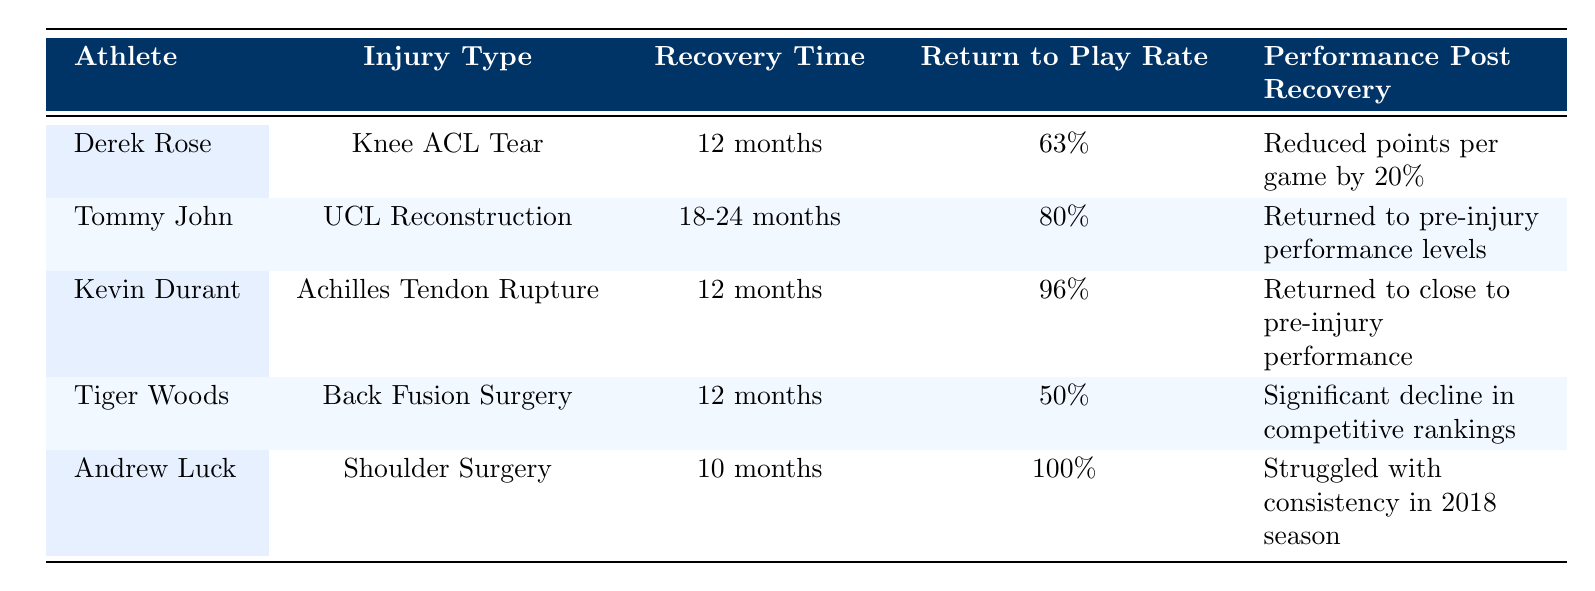What is the recovery time for Derek Rose? According to the table, the recovery time for Derek Rose who suffered from a Knee ACL Tear is noted as 12 months.
Answer: 12 months What is the return to play rate after shoulder surgery for Andrew Luck? The return to play rate for Andrew Luck after undergoing shoulder surgery is listed as 100% in the table.
Answer: 100% Which athlete experienced a significant decline in competitive rankings post-recovery? The table indicates that Tiger Woods, after his Back Fusion Surgery, experienced a significant decline in competitive rankings post-recovery.
Answer: Tiger Woods What injury type has the longest recovery time listed in the table? In the table, Tommy John who underwent UCL Reconstruction has the longest recovery time listed, which is between 18-24 months.
Answer: UCL Reconstruction Is it true that Kevin Durant returned to his pre-injury performance levels? According to the table, Kevin Durant returned to close to pre-injury performance, but it does not state he returned to complete pre-injury performance levels. Therefore, the statement is not entirely true.
Answer: No What is the average return to play rate of all athletes listed in the table? To calculate the average return to play rate: (63% + 80% + 96% + 50% + 100%) / 5 = 389% / 5 = 77.8%. Therefore, the average return to play rate is 77.8%.
Answer: 77.8% How many athletes had a recovery time of 12 months? In the table, three athletes (Derek Rose, Kevin Durant, and Tiger Woods) had a recovery time of 12 months, making the count three.
Answer: 3 Did any athlete have a higher return to play rate than Andrew Luck? Andrew Luck had a return to play rate of 100%, and no other athlete in the table has a higher percentage, only equal or less. Hence, the answer is no.
Answer: No What is the performance post-recovery for Tommy John? The table states that Tommy John returned to his pre-injury performance levels after recovery from UCL Reconstruction.
Answer: Returned to pre-injury performance levels 